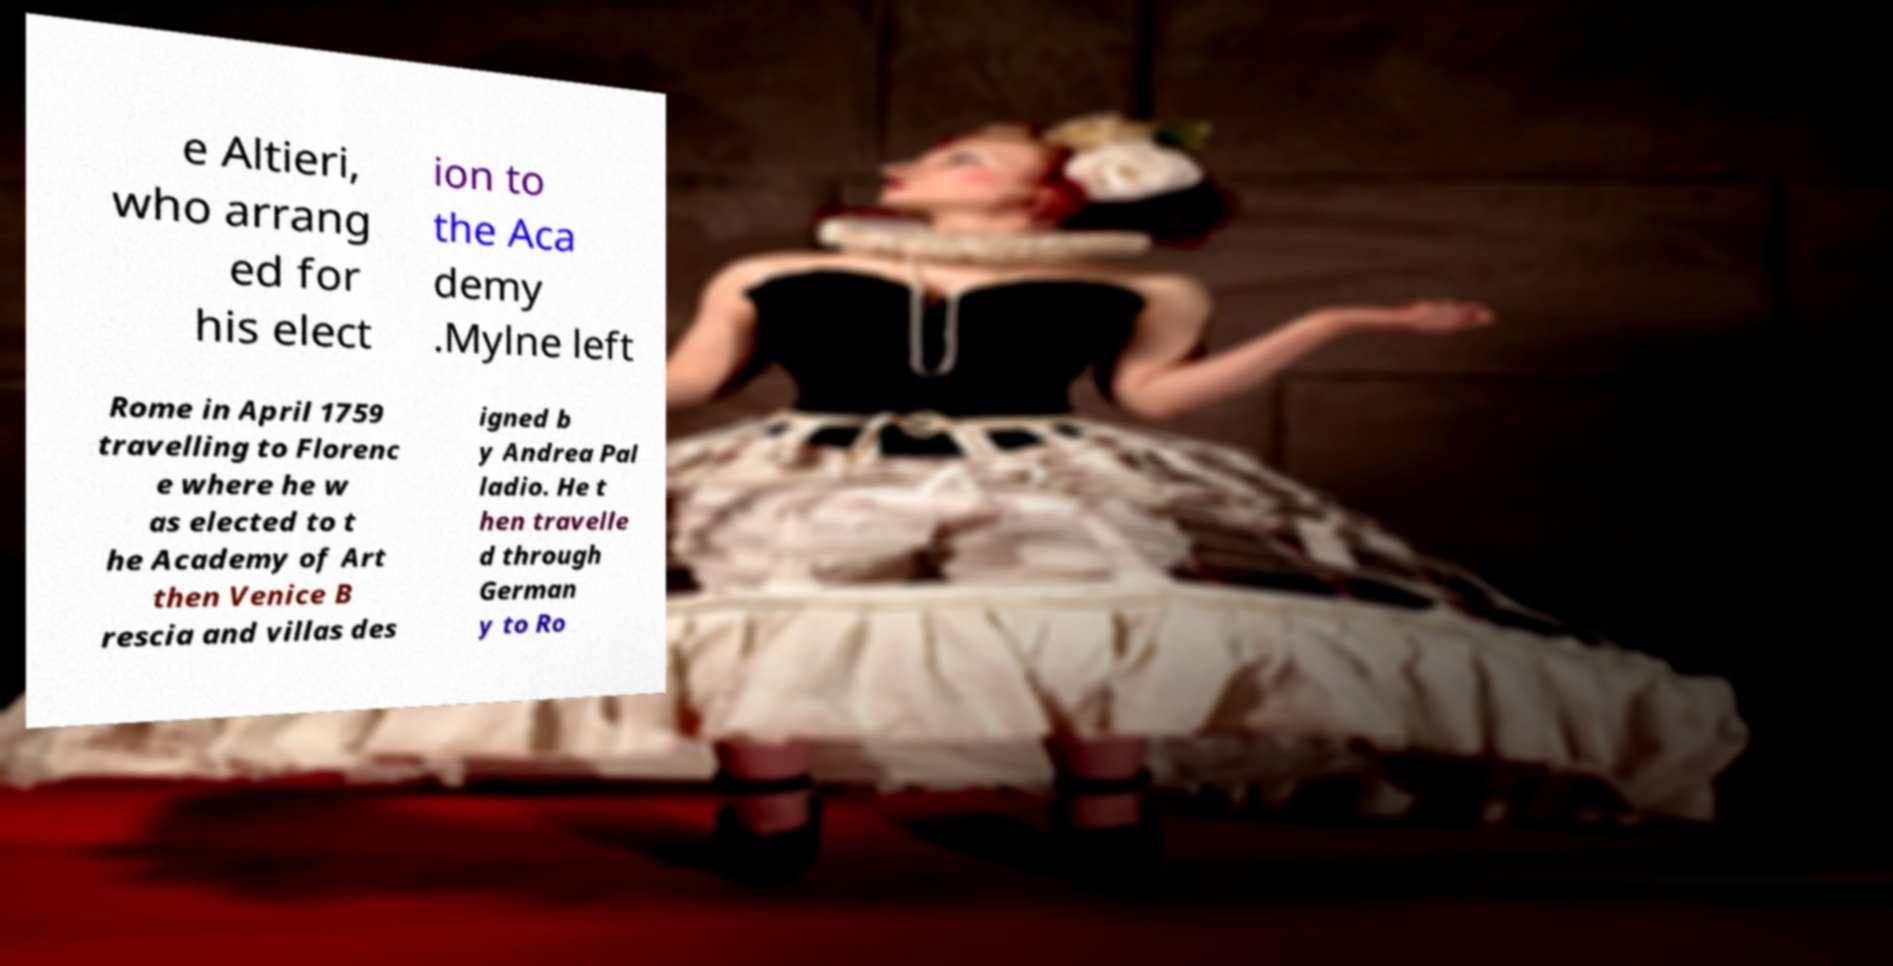Please identify and transcribe the text found in this image. e Altieri, who arrang ed for his elect ion to the Aca demy .Mylne left Rome in April 1759 travelling to Florenc e where he w as elected to t he Academy of Art then Venice B rescia and villas des igned b y Andrea Pal ladio. He t hen travelle d through German y to Ro 